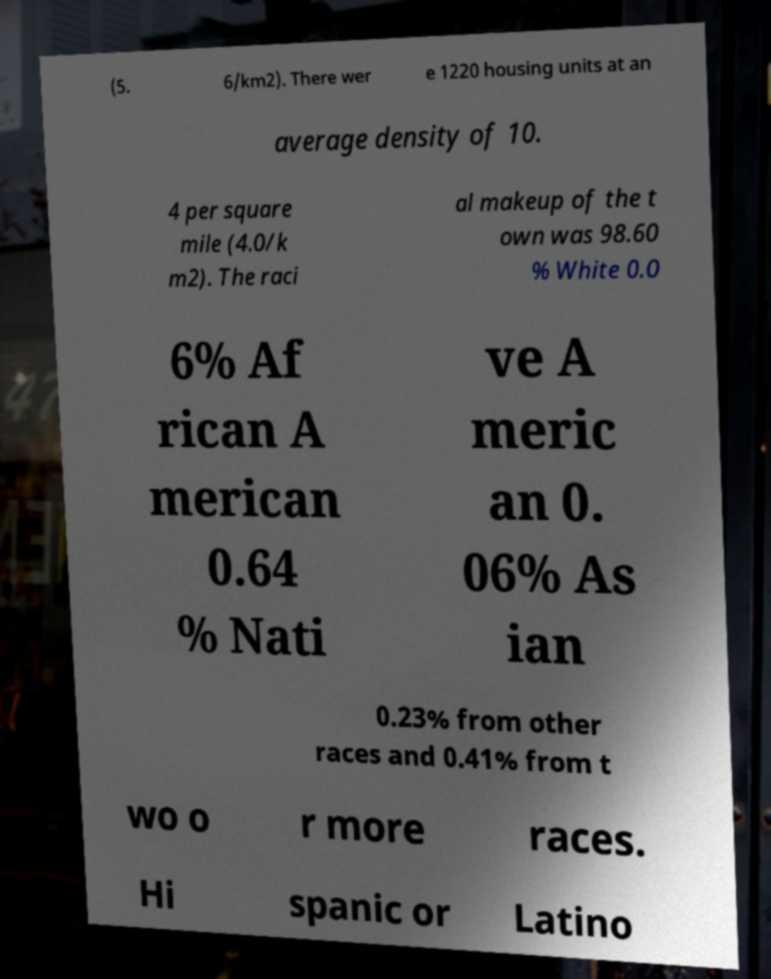For documentation purposes, I need the text within this image transcribed. Could you provide that? (5. 6/km2). There wer e 1220 housing units at an average density of 10. 4 per square mile (4.0/k m2). The raci al makeup of the t own was 98.60 % White 0.0 6% Af rican A merican 0.64 % Nati ve A meric an 0. 06% As ian 0.23% from other races and 0.41% from t wo o r more races. Hi spanic or Latino 